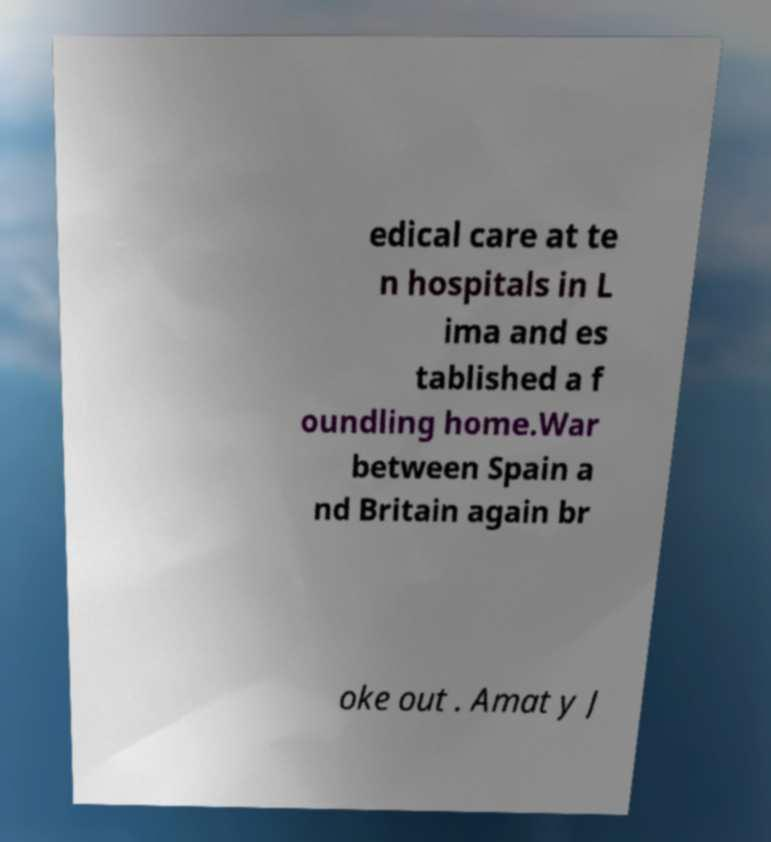What messages or text are displayed in this image? I need them in a readable, typed format. edical care at te n hospitals in L ima and es tablished a f oundling home.War between Spain a nd Britain again br oke out . Amat y J 